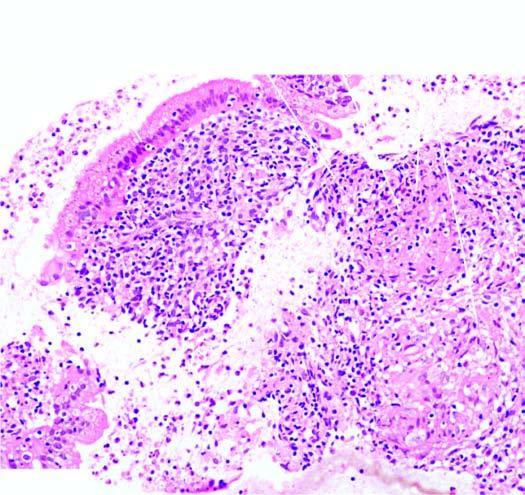has the stroma caseating epithelioid cell granulomas having langhans 'giant cells and peripheral layer of lymphocytes?
Answer the question using a single word or phrase. Yes 